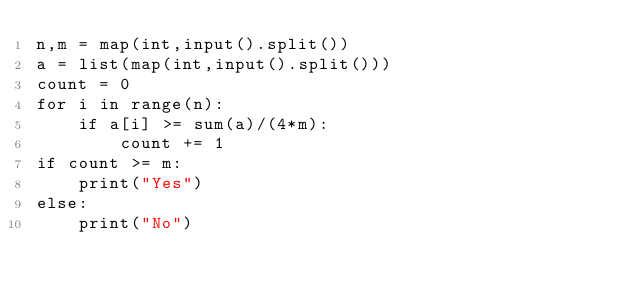Convert code to text. <code><loc_0><loc_0><loc_500><loc_500><_Python_>n,m = map(int,input().split())
a = list(map(int,input().split()))
count = 0
for i in range(n):
    if a[i] >= sum(a)/(4*m):
        count += 1
if count >= m:
    print("Yes")
else:
    print("No")</code> 